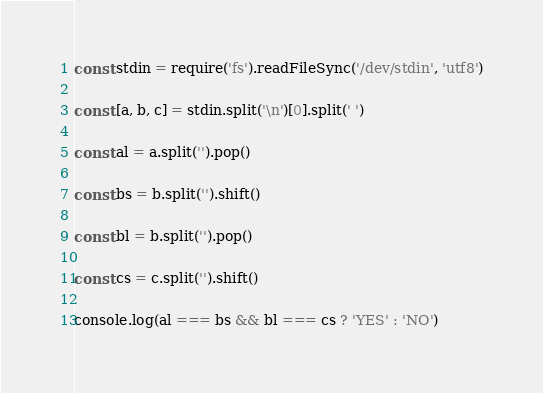<code> <loc_0><loc_0><loc_500><loc_500><_TypeScript_>const stdin = require('fs').readFileSync('/dev/stdin', 'utf8')

const [a, b, c] = stdin.split('\n')[0].split(' ')

const al = a.split('').pop()

const bs = b.split('').shift()

const bl = b.split('').pop()

const cs = c.split('').shift()

console.log(al === bs && bl === cs ? 'YES' : 'NO')
</code> 